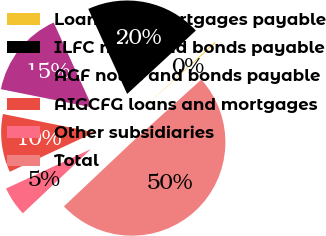Convert chart. <chart><loc_0><loc_0><loc_500><loc_500><pie_chart><fcel>Loans and mortgages payable<fcel>ILFC notes and bonds payable<fcel>AGF notes and bonds payable<fcel>AIGCFG loans and mortgages<fcel>Other subsidiaries<fcel>Total<nl><fcel>0.18%<fcel>19.96%<fcel>15.02%<fcel>10.07%<fcel>5.12%<fcel>49.64%<nl></chart> 